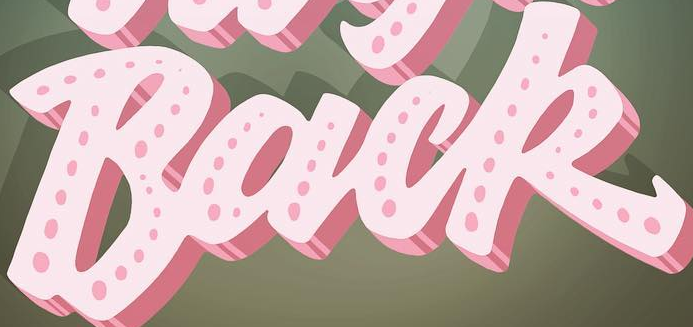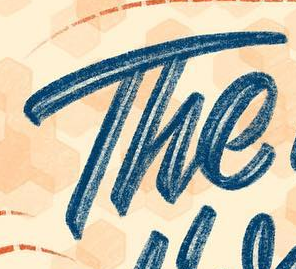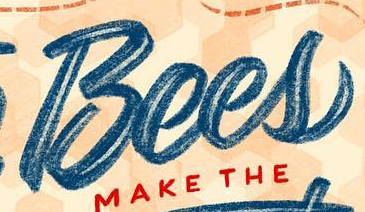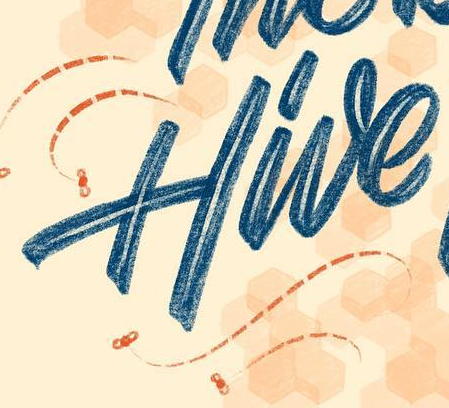Transcribe the words shown in these images in order, separated by a semicolon. Back; The; Bees; Hive 